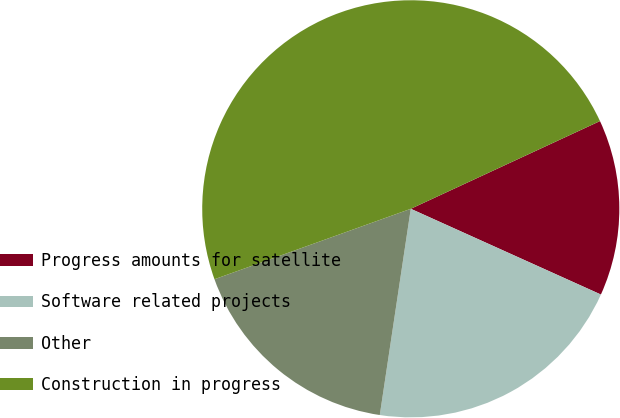Convert chart to OTSL. <chart><loc_0><loc_0><loc_500><loc_500><pie_chart><fcel>Progress amounts for satellite<fcel>Software related projects<fcel>Other<fcel>Construction in progress<nl><fcel>13.65%<fcel>20.63%<fcel>17.14%<fcel>48.57%<nl></chart> 